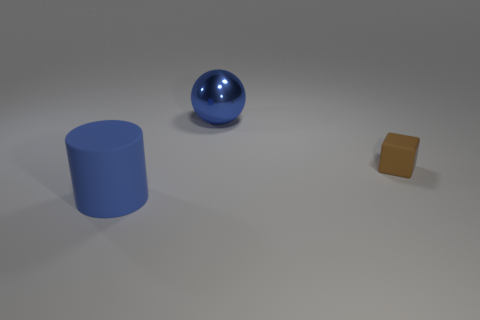Add 1 large metallic objects. How many objects exist? 4 Subtract all blocks. How many objects are left? 2 Add 1 big blue cylinders. How many big blue cylinders exist? 2 Subtract 1 blue cylinders. How many objects are left? 2 Subtract all matte cylinders. Subtract all matte things. How many objects are left? 0 Add 3 brown cubes. How many brown cubes are left? 4 